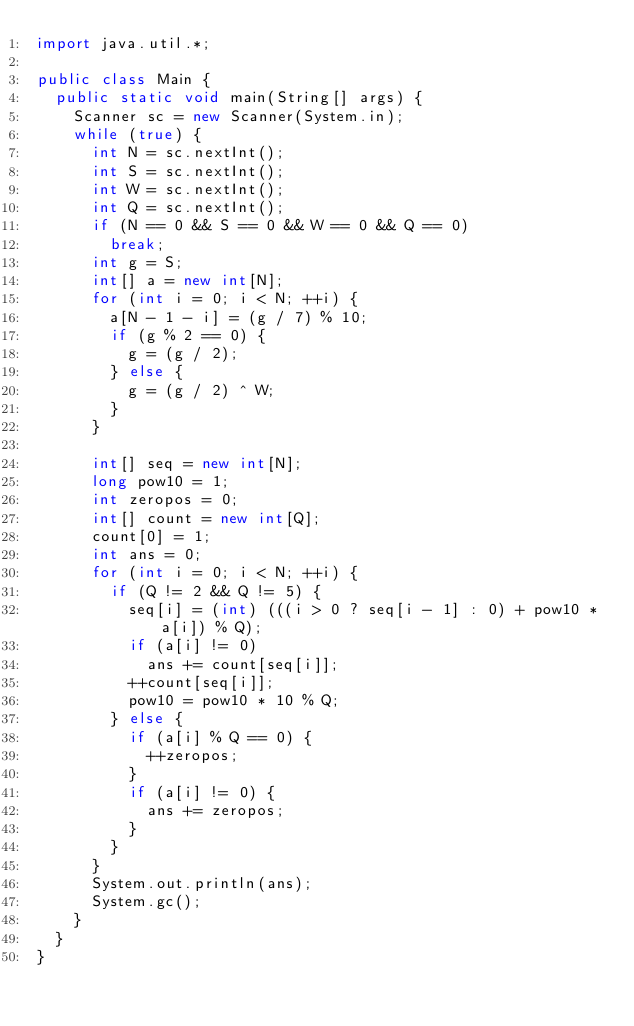<code> <loc_0><loc_0><loc_500><loc_500><_Java_>import java.util.*;

public class Main {
	public static void main(String[] args) {
		Scanner sc = new Scanner(System.in);
		while (true) {
			int N = sc.nextInt();
			int S = sc.nextInt();
			int W = sc.nextInt();
			int Q = sc.nextInt();
			if (N == 0 && S == 0 && W == 0 && Q == 0)
				break;
			int g = S;
			int[] a = new int[N];
			for (int i = 0; i < N; ++i) {
				a[N - 1 - i] = (g / 7) % 10;
				if (g % 2 == 0) {
					g = (g / 2);
				} else {
					g = (g / 2) ^ W;
				}
			}

			int[] seq = new int[N];
			long pow10 = 1;
			int zeropos = 0;
			int[] count = new int[Q];
			count[0] = 1;
			int ans = 0;
			for (int i = 0; i < N; ++i) {
				if (Q != 2 && Q != 5) {
					seq[i] = (int) (((i > 0 ? seq[i - 1] : 0) + pow10 * a[i]) % Q);
					if (a[i] != 0)
						ans += count[seq[i]];
					++count[seq[i]];
					pow10 = pow10 * 10 % Q;
				} else {
					if (a[i] % Q == 0) {
						++zeropos;
					}
					if (a[i] != 0) {
						ans += zeropos;
					}
				}
			}
			System.out.println(ans);
			System.gc();
		}
	}
}</code> 